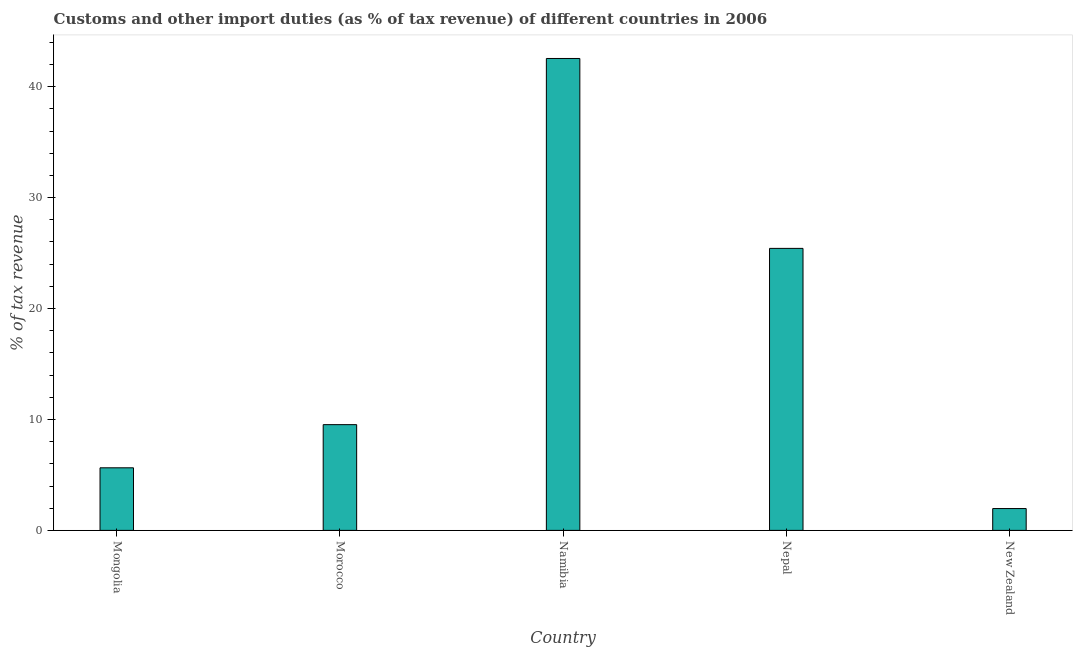What is the title of the graph?
Your answer should be very brief. Customs and other import duties (as % of tax revenue) of different countries in 2006. What is the label or title of the X-axis?
Your answer should be compact. Country. What is the label or title of the Y-axis?
Your answer should be compact. % of tax revenue. What is the customs and other import duties in New Zealand?
Ensure brevity in your answer.  1.97. Across all countries, what is the maximum customs and other import duties?
Give a very brief answer. 42.54. Across all countries, what is the minimum customs and other import duties?
Your response must be concise. 1.97. In which country was the customs and other import duties maximum?
Provide a succinct answer. Namibia. In which country was the customs and other import duties minimum?
Your answer should be very brief. New Zealand. What is the sum of the customs and other import duties?
Offer a very short reply. 85.1. What is the difference between the customs and other import duties in Morocco and Nepal?
Offer a very short reply. -15.89. What is the average customs and other import duties per country?
Give a very brief answer. 17.02. What is the median customs and other import duties?
Keep it short and to the point. 9.53. What is the ratio of the customs and other import duties in Morocco to that in New Zealand?
Give a very brief answer. 4.84. Is the customs and other import duties in Namibia less than that in Nepal?
Provide a succinct answer. No. What is the difference between the highest and the second highest customs and other import duties?
Your response must be concise. 17.12. What is the difference between the highest and the lowest customs and other import duties?
Provide a succinct answer. 40.57. In how many countries, is the customs and other import duties greater than the average customs and other import duties taken over all countries?
Offer a very short reply. 2. How many bars are there?
Give a very brief answer. 5. Are the values on the major ticks of Y-axis written in scientific E-notation?
Provide a short and direct response. No. What is the % of tax revenue in Mongolia?
Your answer should be very brief. 5.64. What is the % of tax revenue of Morocco?
Your answer should be very brief. 9.53. What is the % of tax revenue in Namibia?
Your response must be concise. 42.54. What is the % of tax revenue in Nepal?
Offer a very short reply. 25.42. What is the % of tax revenue in New Zealand?
Your answer should be compact. 1.97. What is the difference between the % of tax revenue in Mongolia and Morocco?
Keep it short and to the point. -3.89. What is the difference between the % of tax revenue in Mongolia and Namibia?
Ensure brevity in your answer.  -36.9. What is the difference between the % of tax revenue in Mongolia and Nepal?
Your answer should be very brief. -19.78. What is the difference between the % of tax revenue in Mongolia and New Zealand?
Offer a terse response. 3.67. What is the difference between the % of tax revenue in Morocco and Namibia?
Ensure brevity in your answer.  -33.01. What is the difference between the % of tax revenue in Morocco and Nepal?
Give a very brief answer. -15.89. What is the difference between the % of tax revenue in Morocco and New Zealand?
Offer a very short reply. 7.56. What is the difference between the % of tax revenue in Namibia and Nepal?
Provide a succinct answer. 17.12. What is the difference between the % of tax revenue in Namibia and New Zealand?
Keep it short and to the point. 40.57. What is the difference between the % of tax revenue in Nepal and New Zealand?
Make the answer very short. 23.45. What is the ratio of the % of tax revenue in Mongolia to that in Morocco?
Provide a succinct answer. 0.59. What is the ratio of the % of tax revenue in Mongolia to that in Namibia?
Provide a succinct answer. 0.13. What is the ratio of the % of tax revenue in Mongolia to that in Nepal?
Your answer should be compact. 0.22. What is the ratio of the % of tax revenue in Mongolia to that in New Zealand?
Offer a very short reply. 2.87. What is the ratio of the % of tax revenue in Morocco to that in Namibia?
Provide a short and direct response. 0.22. What is the ratio of the % of tax revenue in Morocco to that in New Zealand?
Ensure brevity in your answer.  4.84. What is the ratio of the % of tax revenue in Namibia to that in Nepal?
Provide a succinct answer. 1.67. What is the ratio of the % of tax revenue in Namibia to that in New Zealand?
Make the answer very short. 21.61. What is the ratio of the % of tax revenue in Nepal to that in New Zealand?
Give a very brief answer. 12.91. 